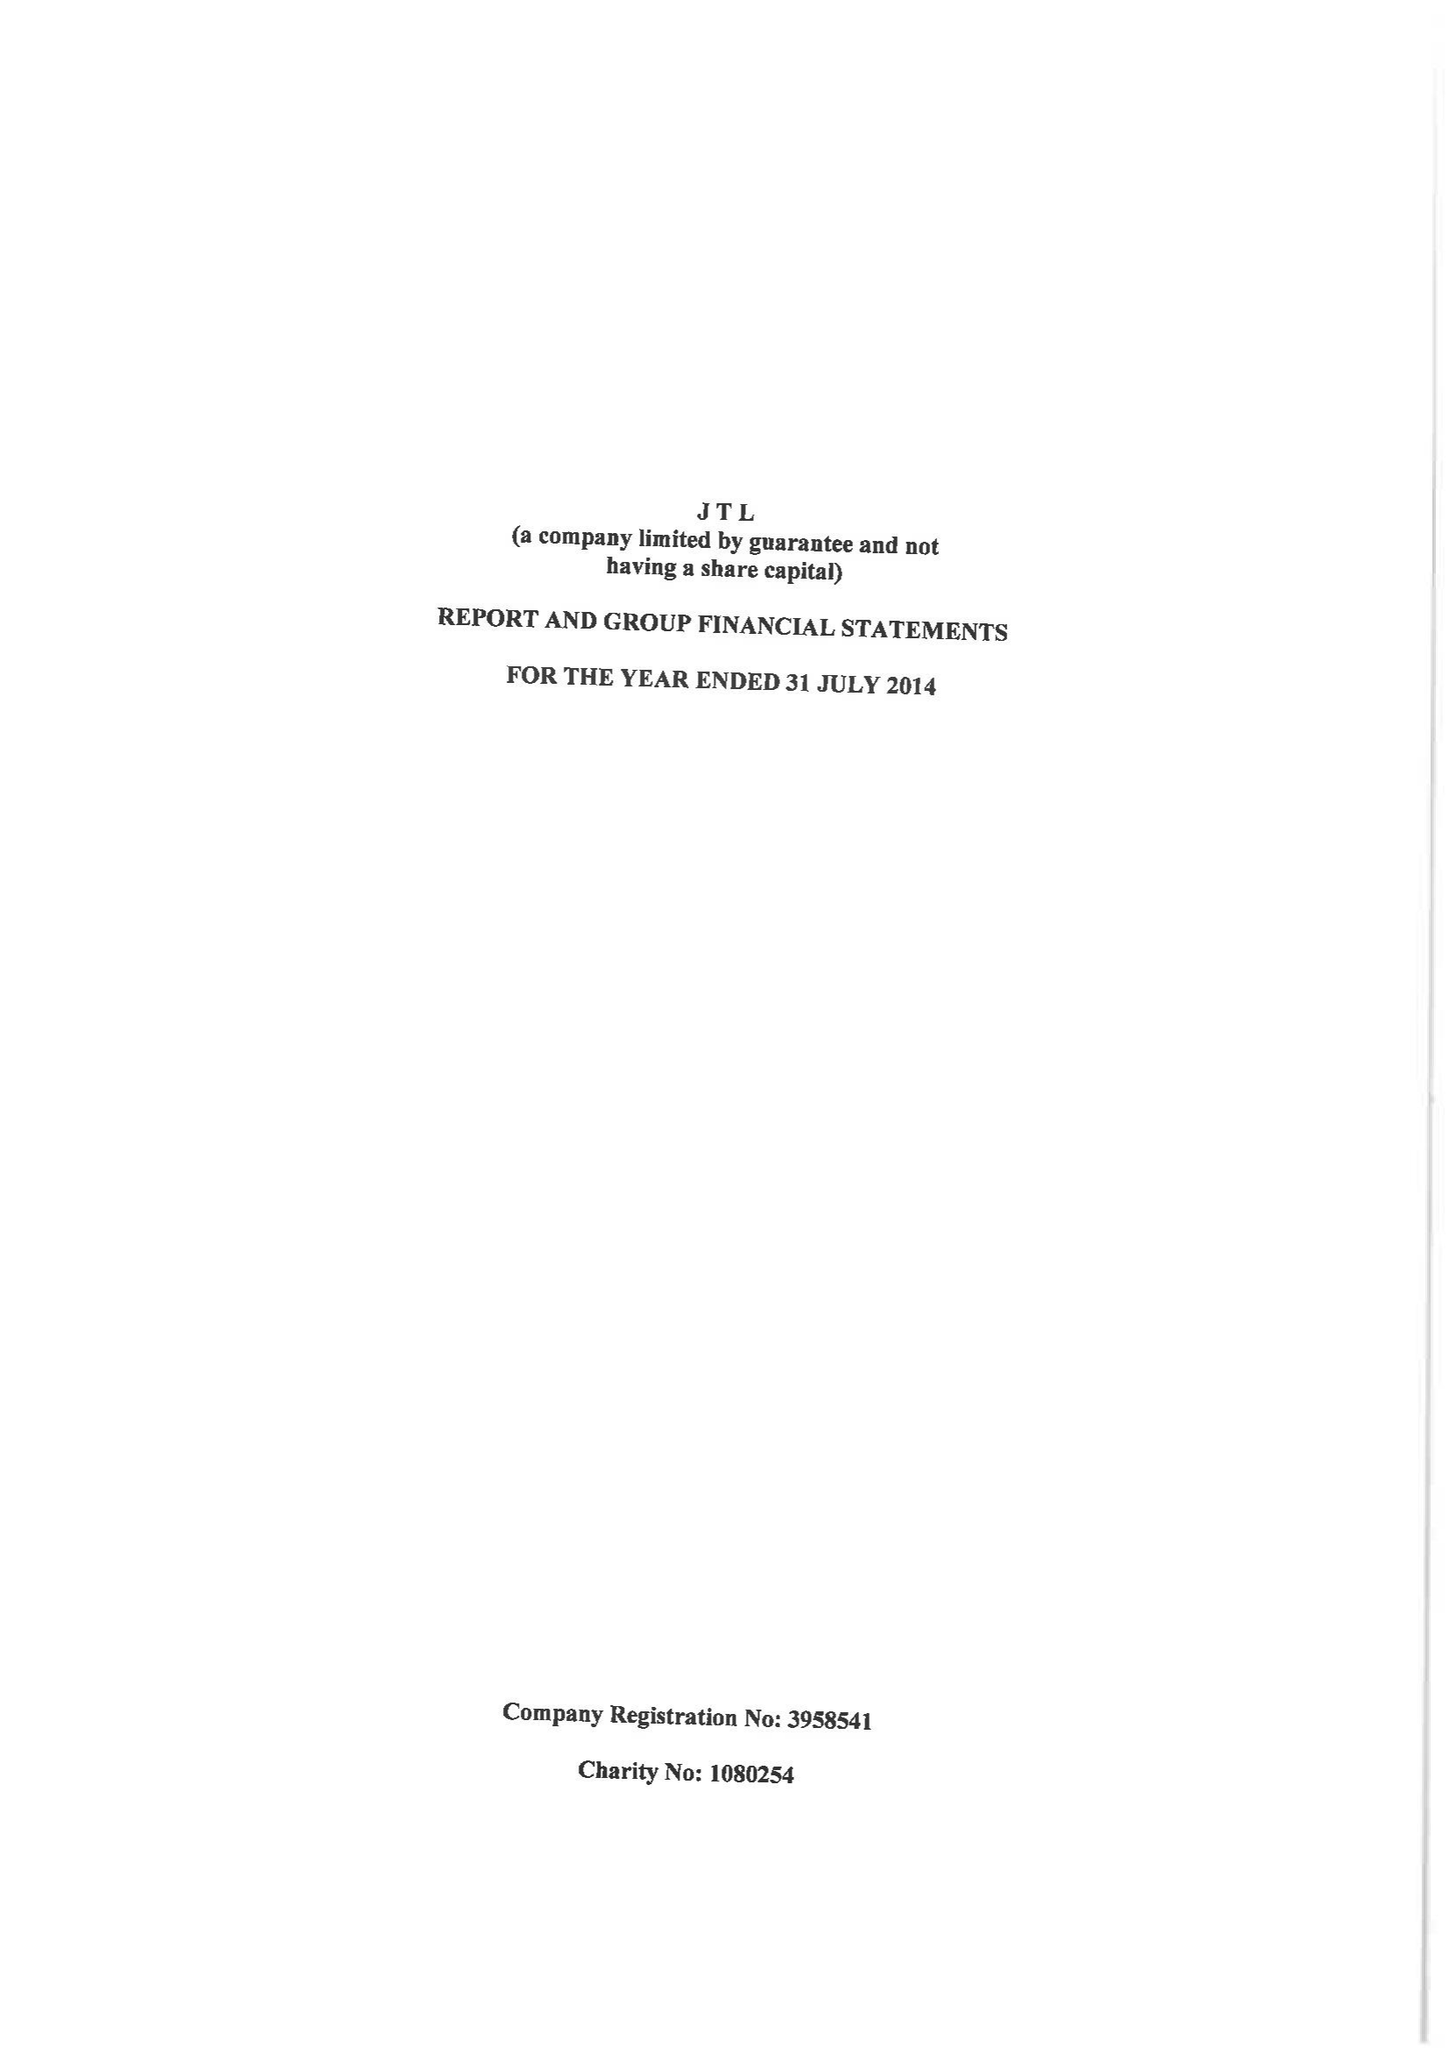What is the value for the spending_annually_in_british_pounds?
Answer the question using a single word or phrase. 22046898.00 